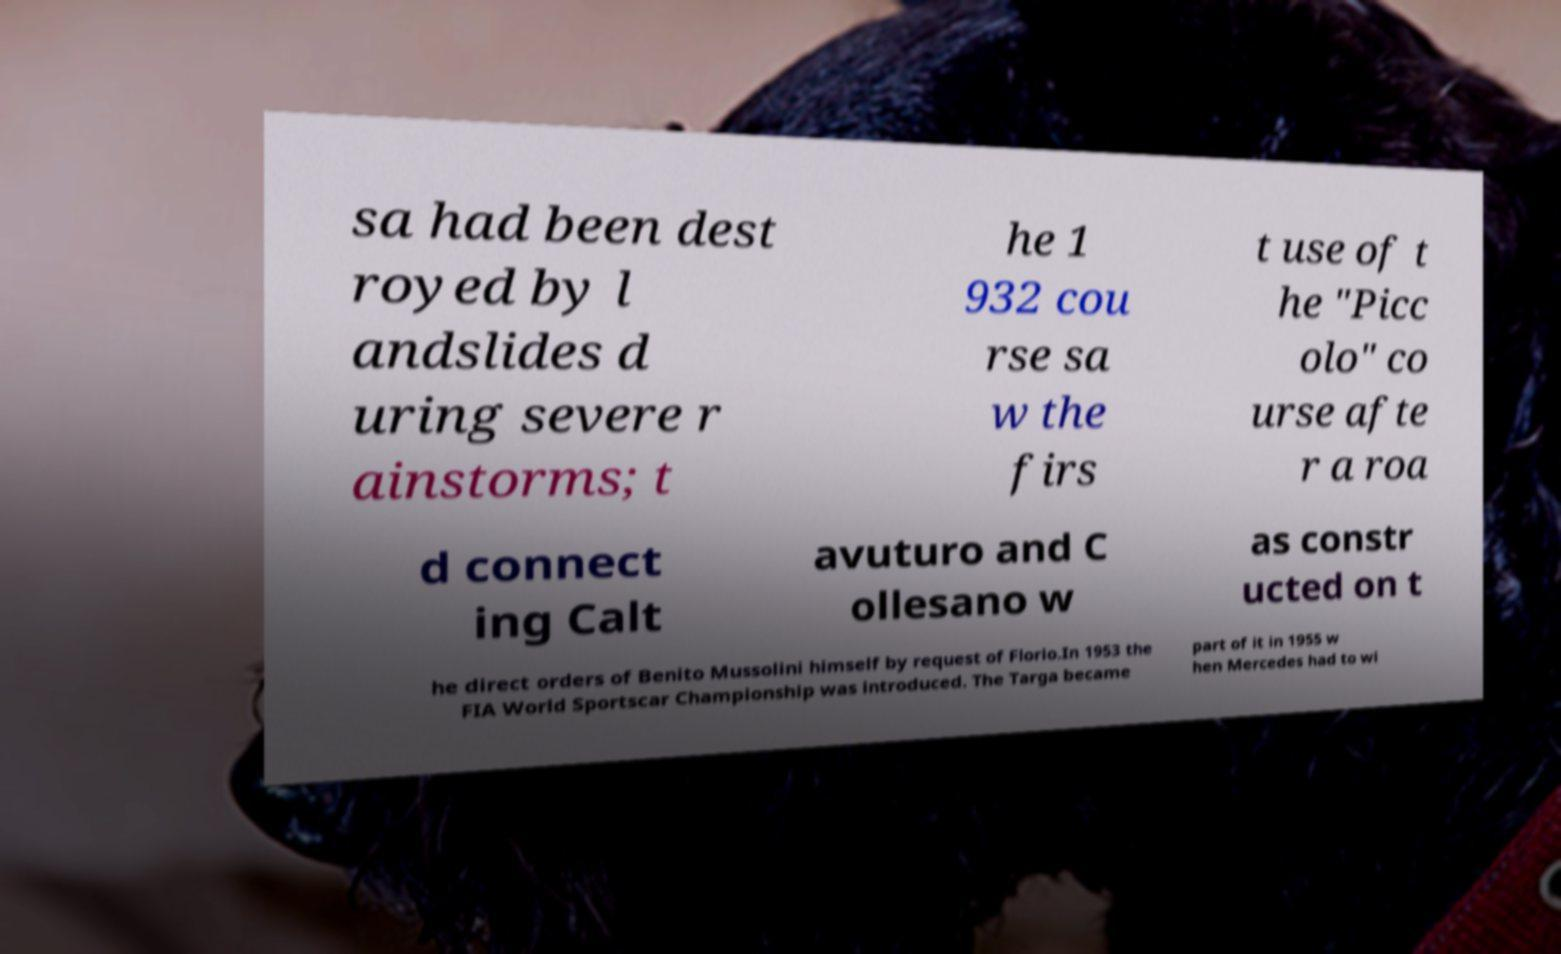What messages or text are displayed in this image? I need them in a readable, typed format. sa had been dest royed by l andslides d uring severe r ainstorms; t he 1 932 cou rse sa w the firs t use of t he "Picc olo" co urse afte r a roa d connect ing Calt avuturo and C ollesano w as constr ucted on t he direct orders of Benito Mussolini himself by request of Florio.In 1953 the FIA World Sportscar Championship was introduced. The Targa became part of it in 1955 w hen Mercedes had to wi 